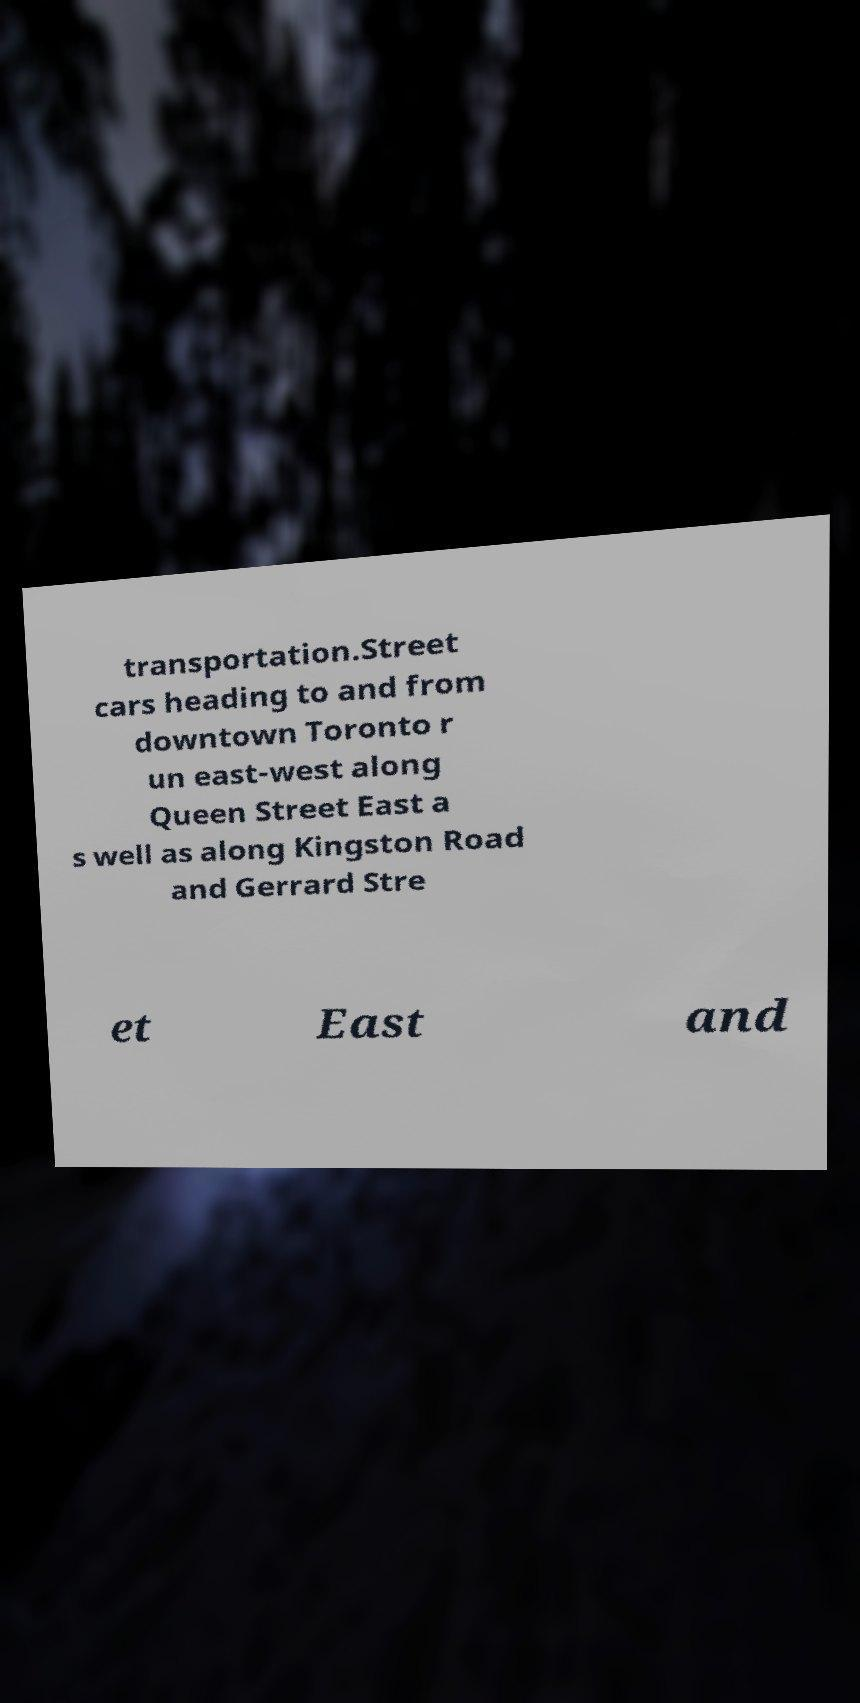Please read and relay the text visible in this image. What does it say? transportation.Street cars heading to and from downtown Toronto r un east-west along Queen Street East a s well as along Kingston Road and Gerrard Stre et East and 